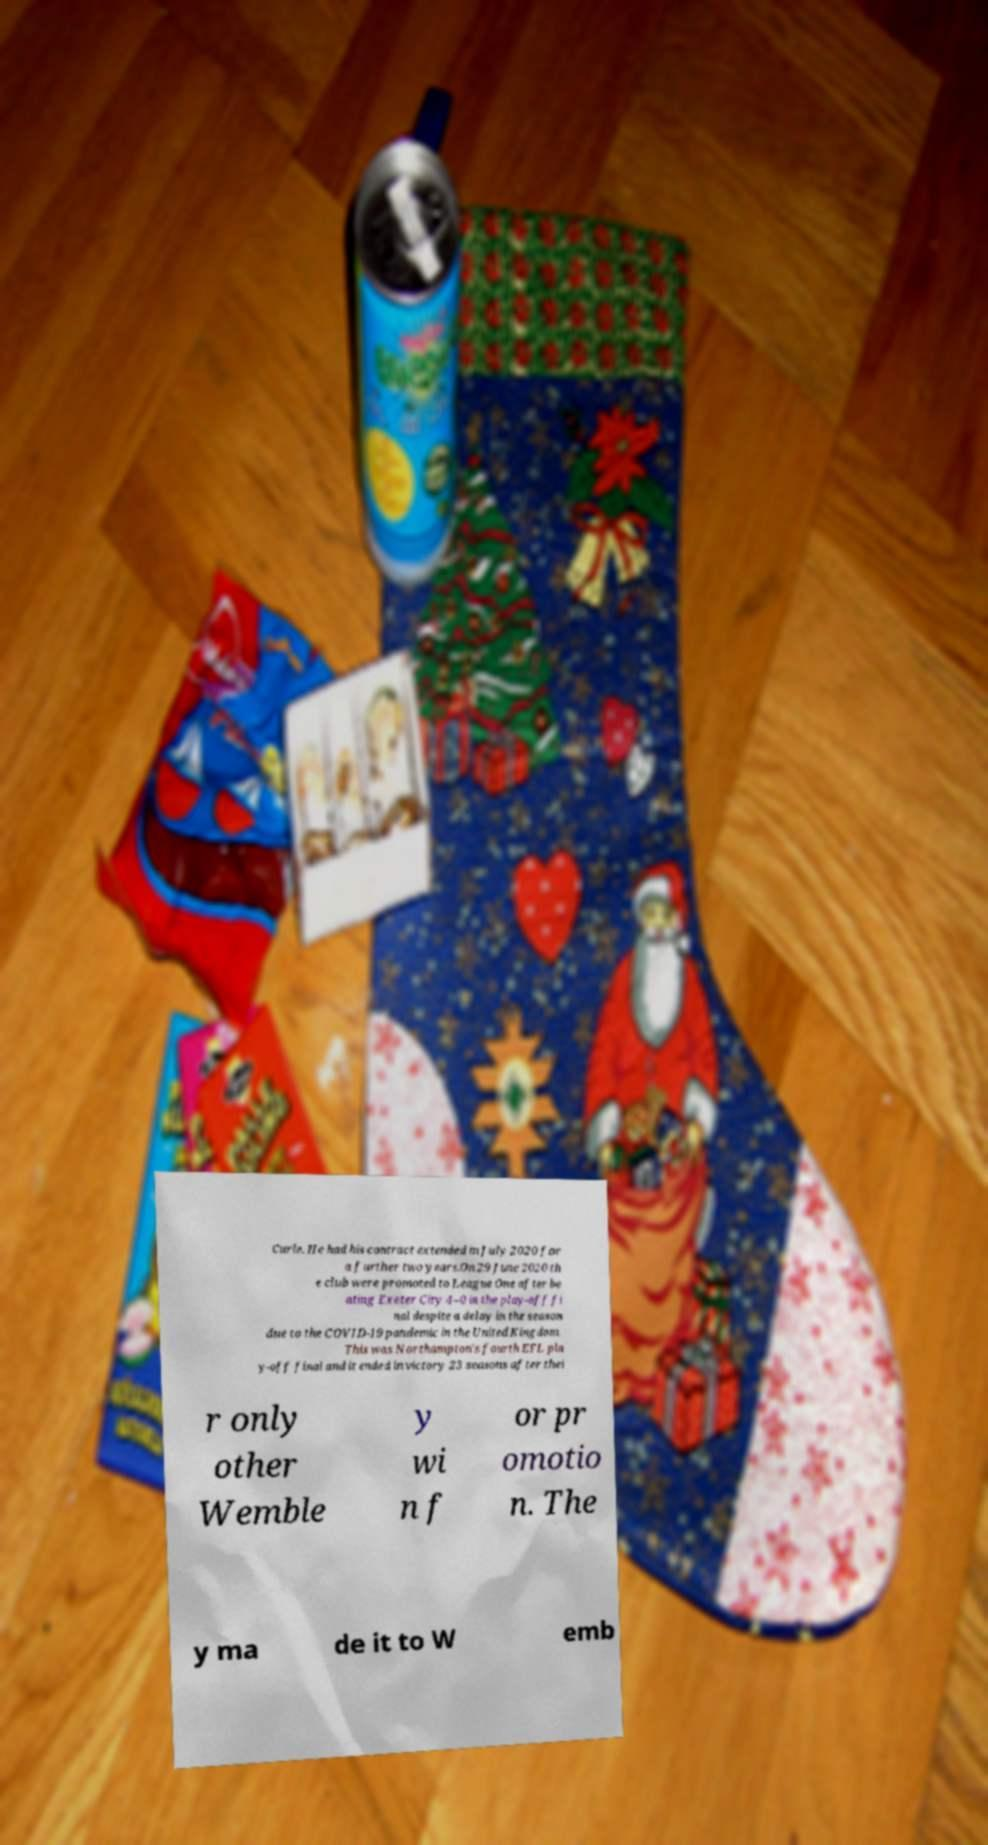What messages or text are displayed in this image? I need them in a readable, typed format. Curle. He had his contract extended in July 2020 for a further two years.On 29 June 2020 th e club were promoted to League One after be ating Exeter City 4–0 in the play-off fi nal despite a delay in the season due to the COVID-19 pandemic in the United Kingdom. This was Northampton's fourth EFL pla y-off final and it ended in victory 23 seasons after thei r only other Wemble y wi n f or pr omotio n. The y ma de it to W emb 